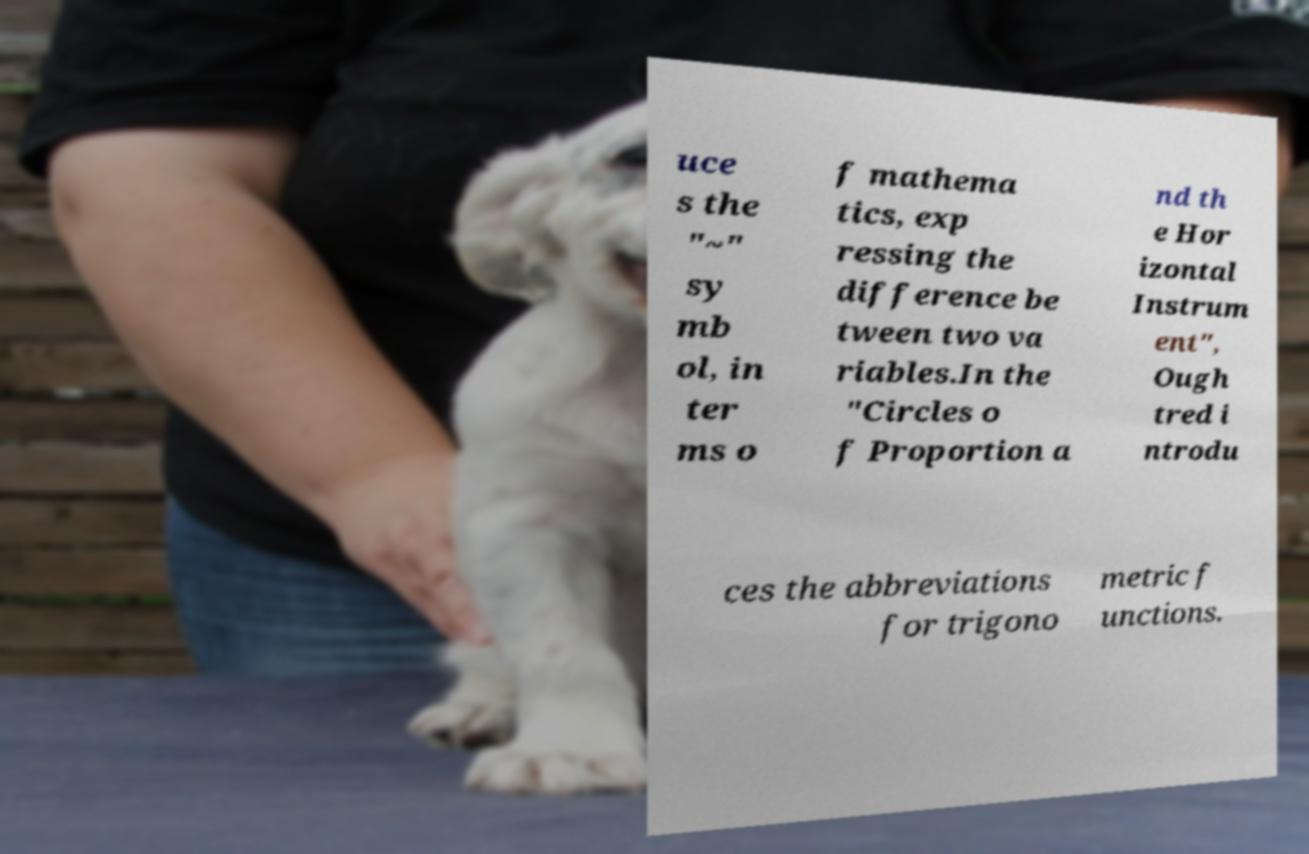There's text embedded in this image that I need extracted. Can you transcribe it verbatim? uce s the "~" sy mb ol, in ter ms o f mathema tics, exp ressing the difference be tween two va riables.In the "Circles o f Proportion a nd th e Hor izontal Instrum ent", Ough tred i ntrodu ces the abbreviations for trigono metric f unctions. 